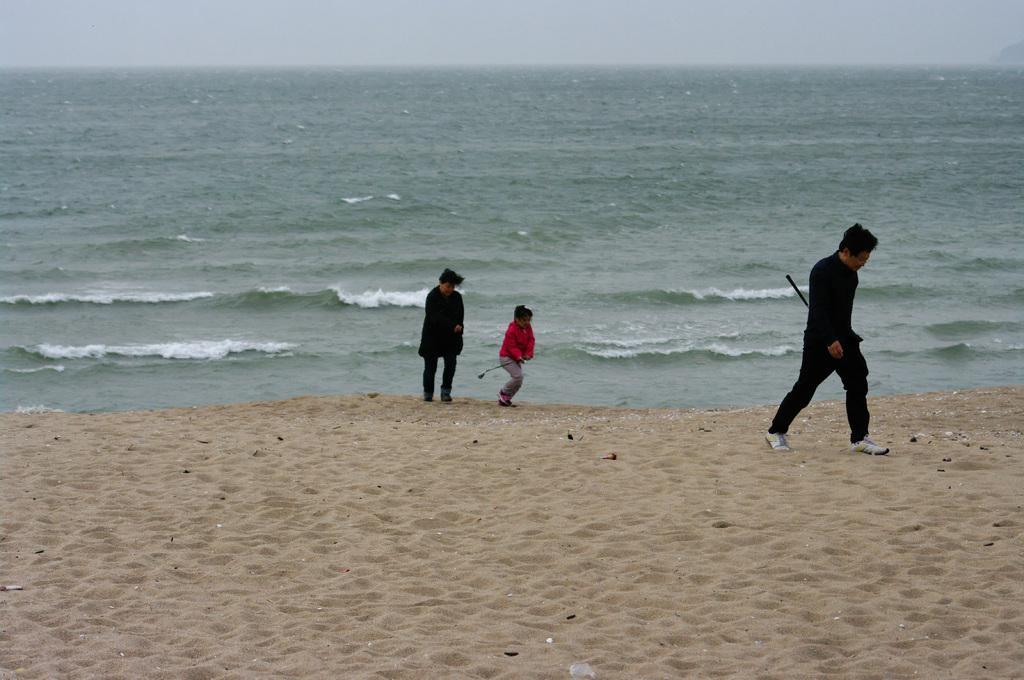Please provide a concise description of this image. In this image in the center there are three persons who are walking, and at the bottom there is sand. In the background there is a beach, and at the top of the image there is sky. 